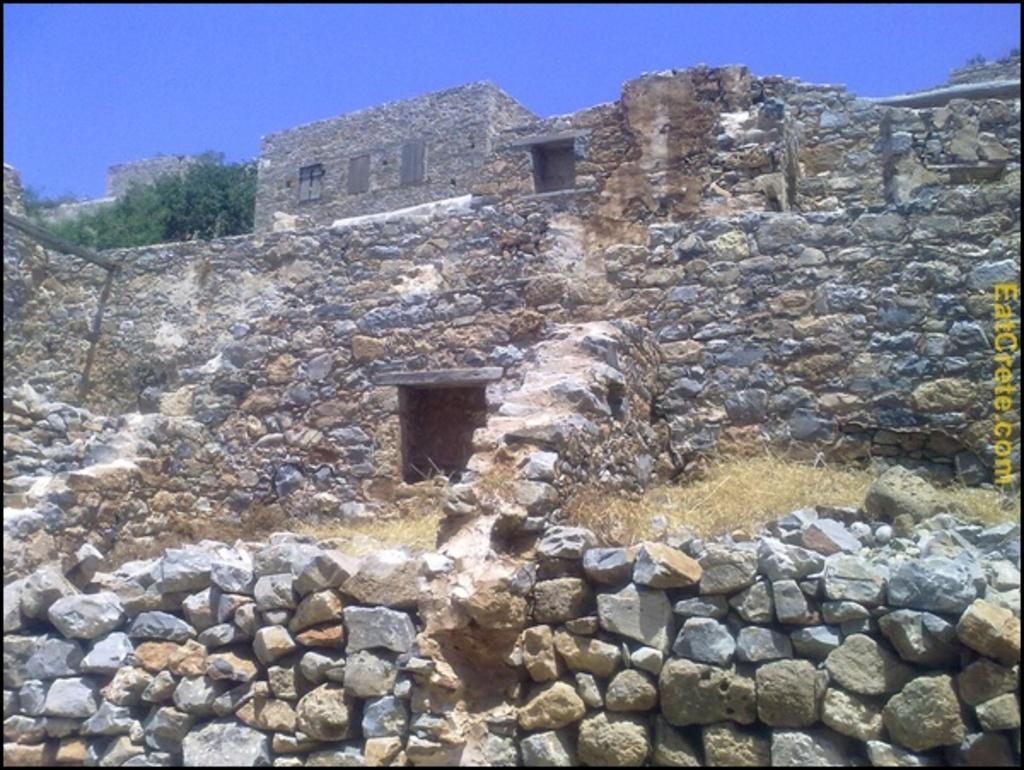Can you describe this image briefly? In the picture I can see rocks, the grass, a fort, trees and the sky. On the right side of the image I can see a watermark. 